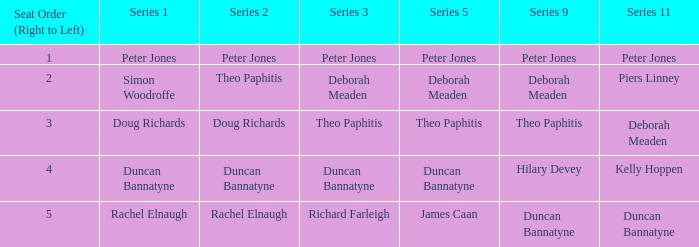How many Seat Orders (Right to Left) have a Series 3 of deborah meaden? 1.0. 